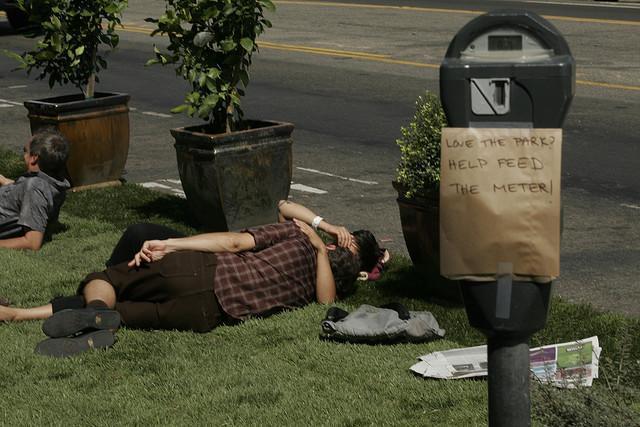How many people are laying on the grass?
Give a very brief answer. 3. How many people are in the photo?
Give a very brief answer. 3. How many potted plants are there?
Give a very brief answer. 3. 